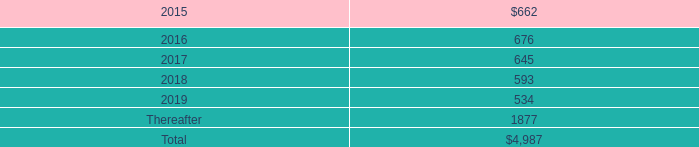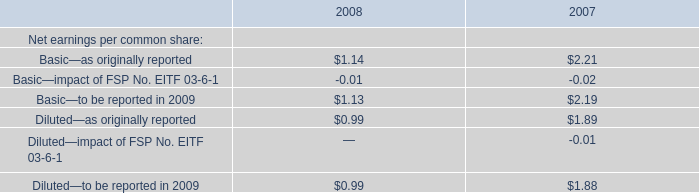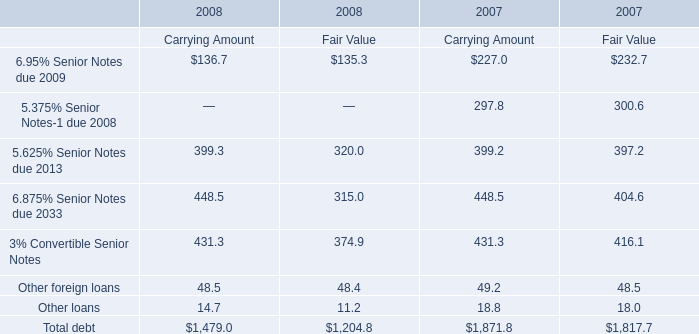what was the change in rent expense under all operating leases , including both cancelable and noncancelable leases between 2014 and 2012 , in millions? 
Computations: (717 - 488)
Answer: 229.0. 